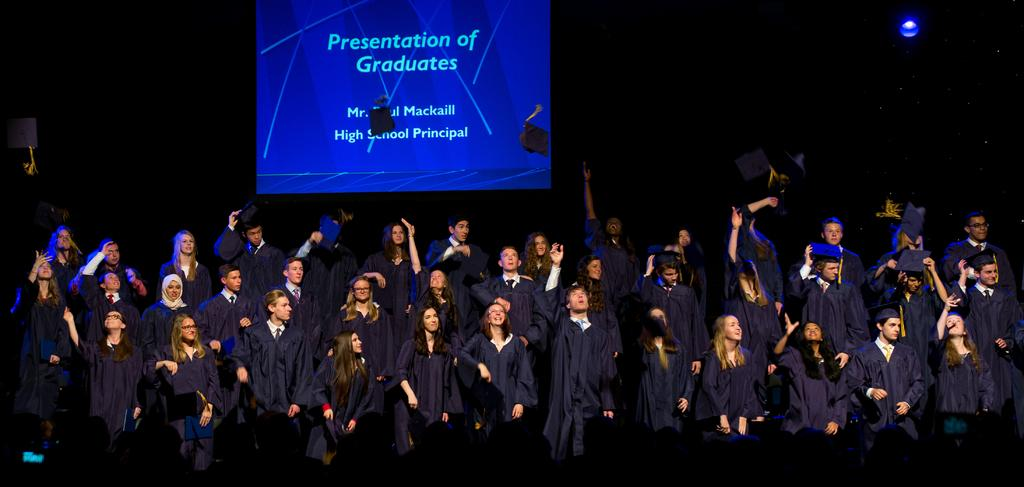How many people are in the image? There are many students in the image. What are the students wearing? The students are wearing aprons. What are some students doing in the image? Some students are throwing caps. What can be seen in the background of the image? There is a screen in the background of the image. How would you describe the lighting in the image? The background is dark. How many rings can be seen on the students' thumbs in the image? There are no rings visible on the students' thumbs in the image. 